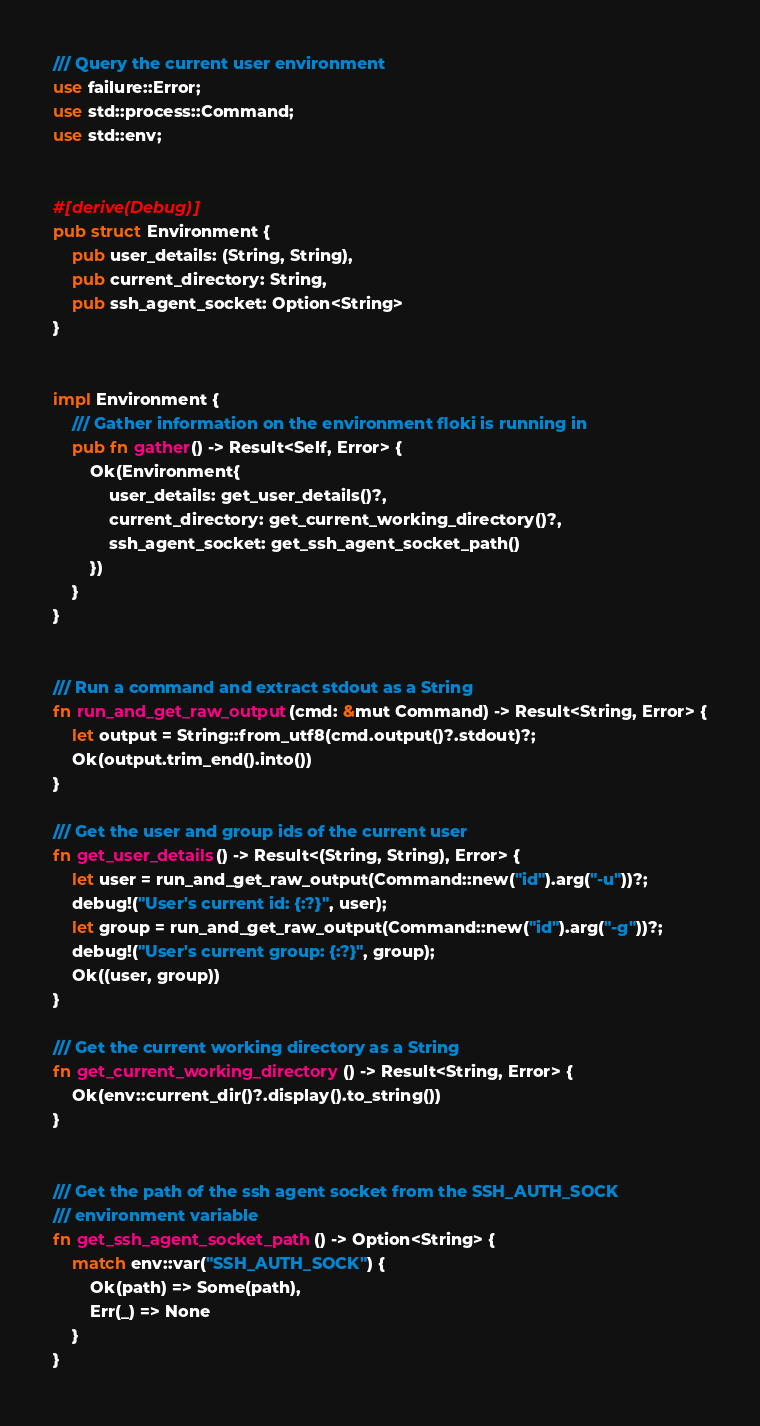Convert code to text. <code><loc_0><loc_0><loc_500><loc_500><_Rust_>/// Query the current user environment
use failure::Error;
use std::process::Command;
use std::env;


#[derive(Debug)]
pub struct Environment {
    pub user_details: (String, String),
    pub current_directory: String,
    pub ssh_agent_socket: Option<String>
}


impl Environment {
    /// Gather information on the environment floki is running in
    pub fn gather() -> Result<Self, Error> {
        Ok(Environment{
            user_details: get_user_details()?,
            current_directory: get_current_working_directory()?,
            ssh_agent_socket: get_ssh_agent_socket_path()
        })
    }
}


/// Run a command and extract stdout as a String
fn run_and_get_raw_output(cmd: &mut Command) -> Result<String, Error> {
    let output = String::from_utf8(cmd.output()?.stdout)?;
    Ok(output.trim_end().into())
}

/// Get the user and group ids of the current user
fn get_user_details() -> Result<(String, String), Error> {
    let user = run_and_get_raw_output(Command::new("id").arg("-u"))?;
    debug!("User's current id: {:?}", user);
    let group = run_and_get_raw_output(Command::new("id").arg("-g"))?;
    debug!("User's current group: {:?}", group);
    Ok((user, group))
}

/// Get the current working directory as a String
fn get_current_working_directory() -> Result<String, Error> {
    Ok(env::current_dir()?.display().to_string())
}


/// Get the path of the ssh agent socket from the SSH_AUTH_SOCK
/// environment variable
fn get_ssh_agent_socket_path() -> Option<String> {
    match env::var("SSH_AUTH_SOCK") {
        Ok(path) => Some(path),
        Err(_) => None
    }
}
</code> 